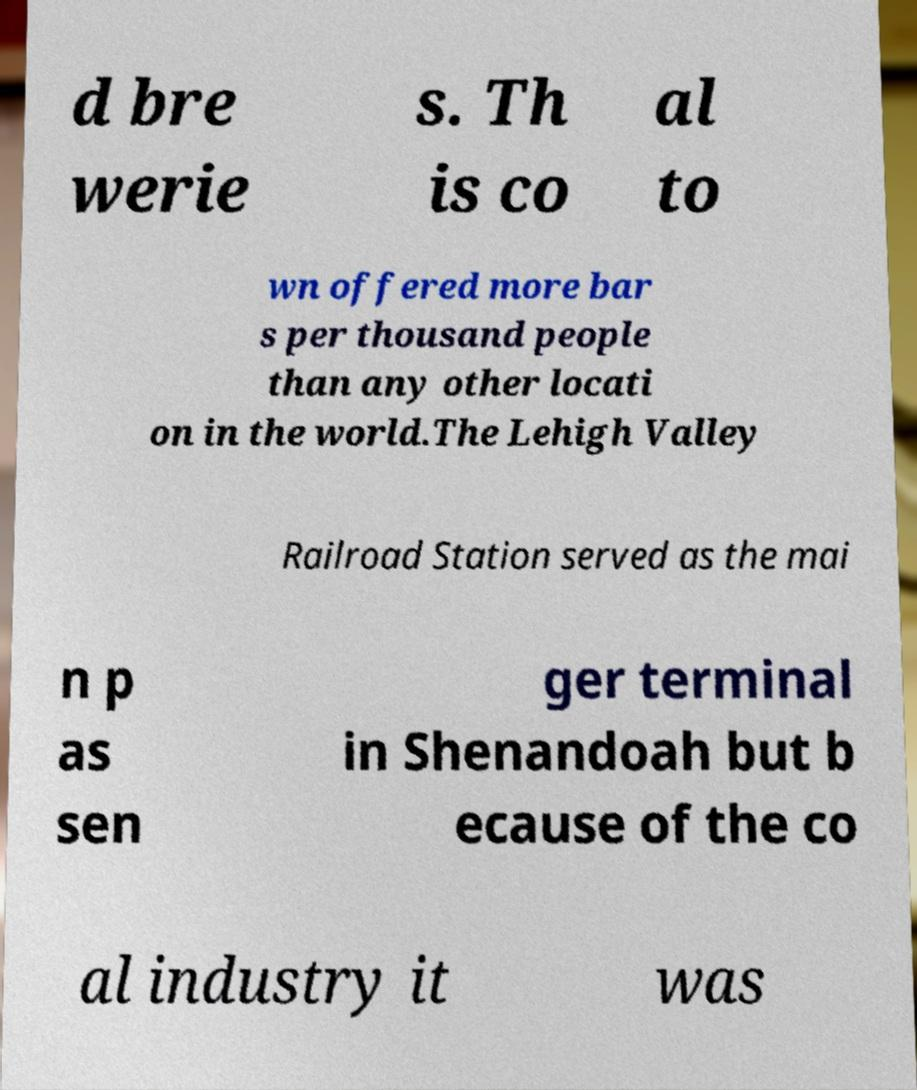Can you read and provide the text displayed in the image?This photo seems to have some interesting text. Can you extract and type it out for me? d bre werie s. Th is co al to wn offered more bar s per thousand people than any other locati on in the world.The Lehigh Valley Railroad Station served as the mai n p as sen ger terminal in Shenandoah but b ecause of the co al industry it was 